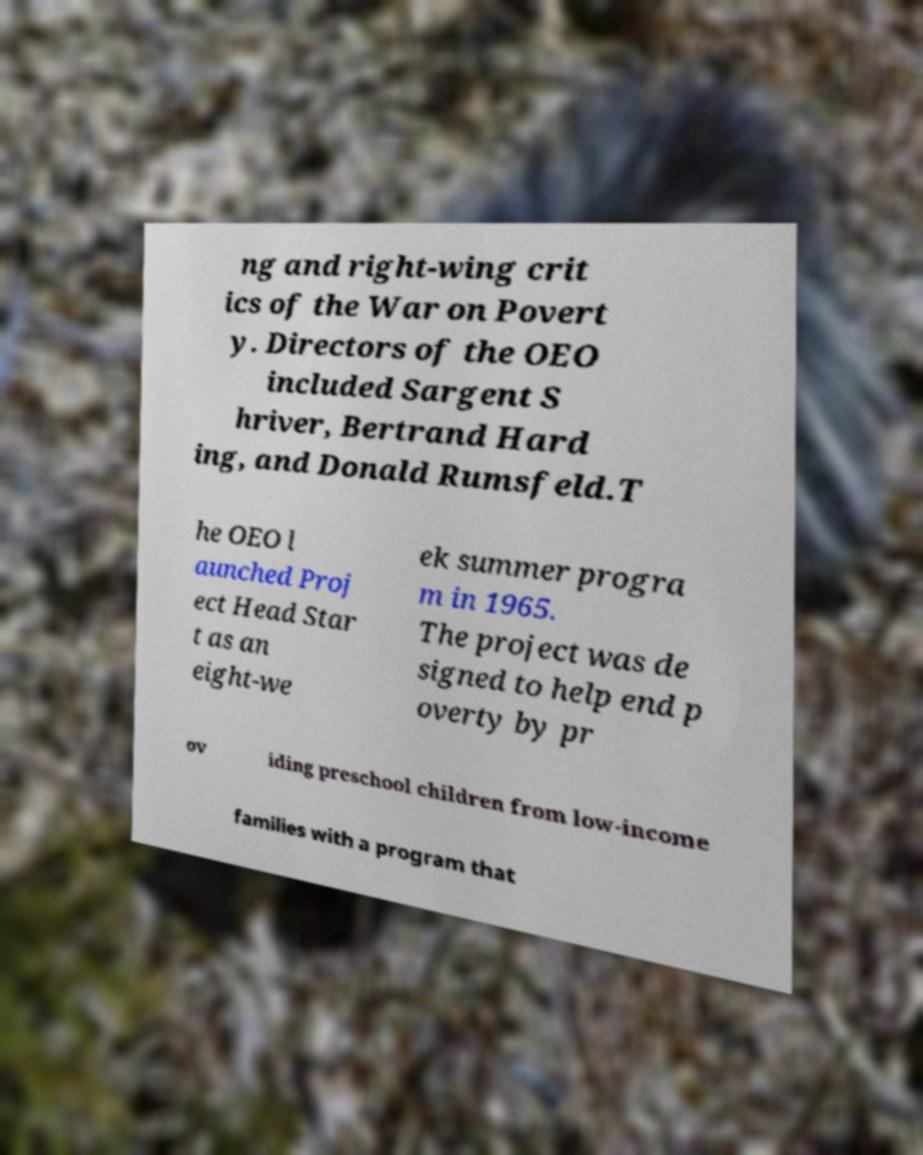For documentation purposes, I need the text within this image transcribed. Could you provide that? ng and right-wing crit ics of the War on Povert y. Directors of the OEO included Sargent S hriver, Bertrand Hard ing, and Donald Rumsfeld.T he OEO l aunched Proj ect Head Star t as an eight-we ek summer progra m in 1965. The project was de signed to help end p overty by pr ov iding preschool children from low-income families with a program that 